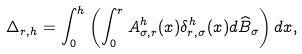Convert formula to latex. <formula><loc_0><loc_0><loc_500><loc_500>\Delta _ { r , h } = \int _ { 0 } ^ { h } \left ( \int _ { 0 } ^ { r } A ^ { h } _ { \sigma , r } ( x ) \delta _ { r , \sigma } ^ { h } ( x ) d \widehat { B } _ { \sigma } \right ) d x ,</formula> 